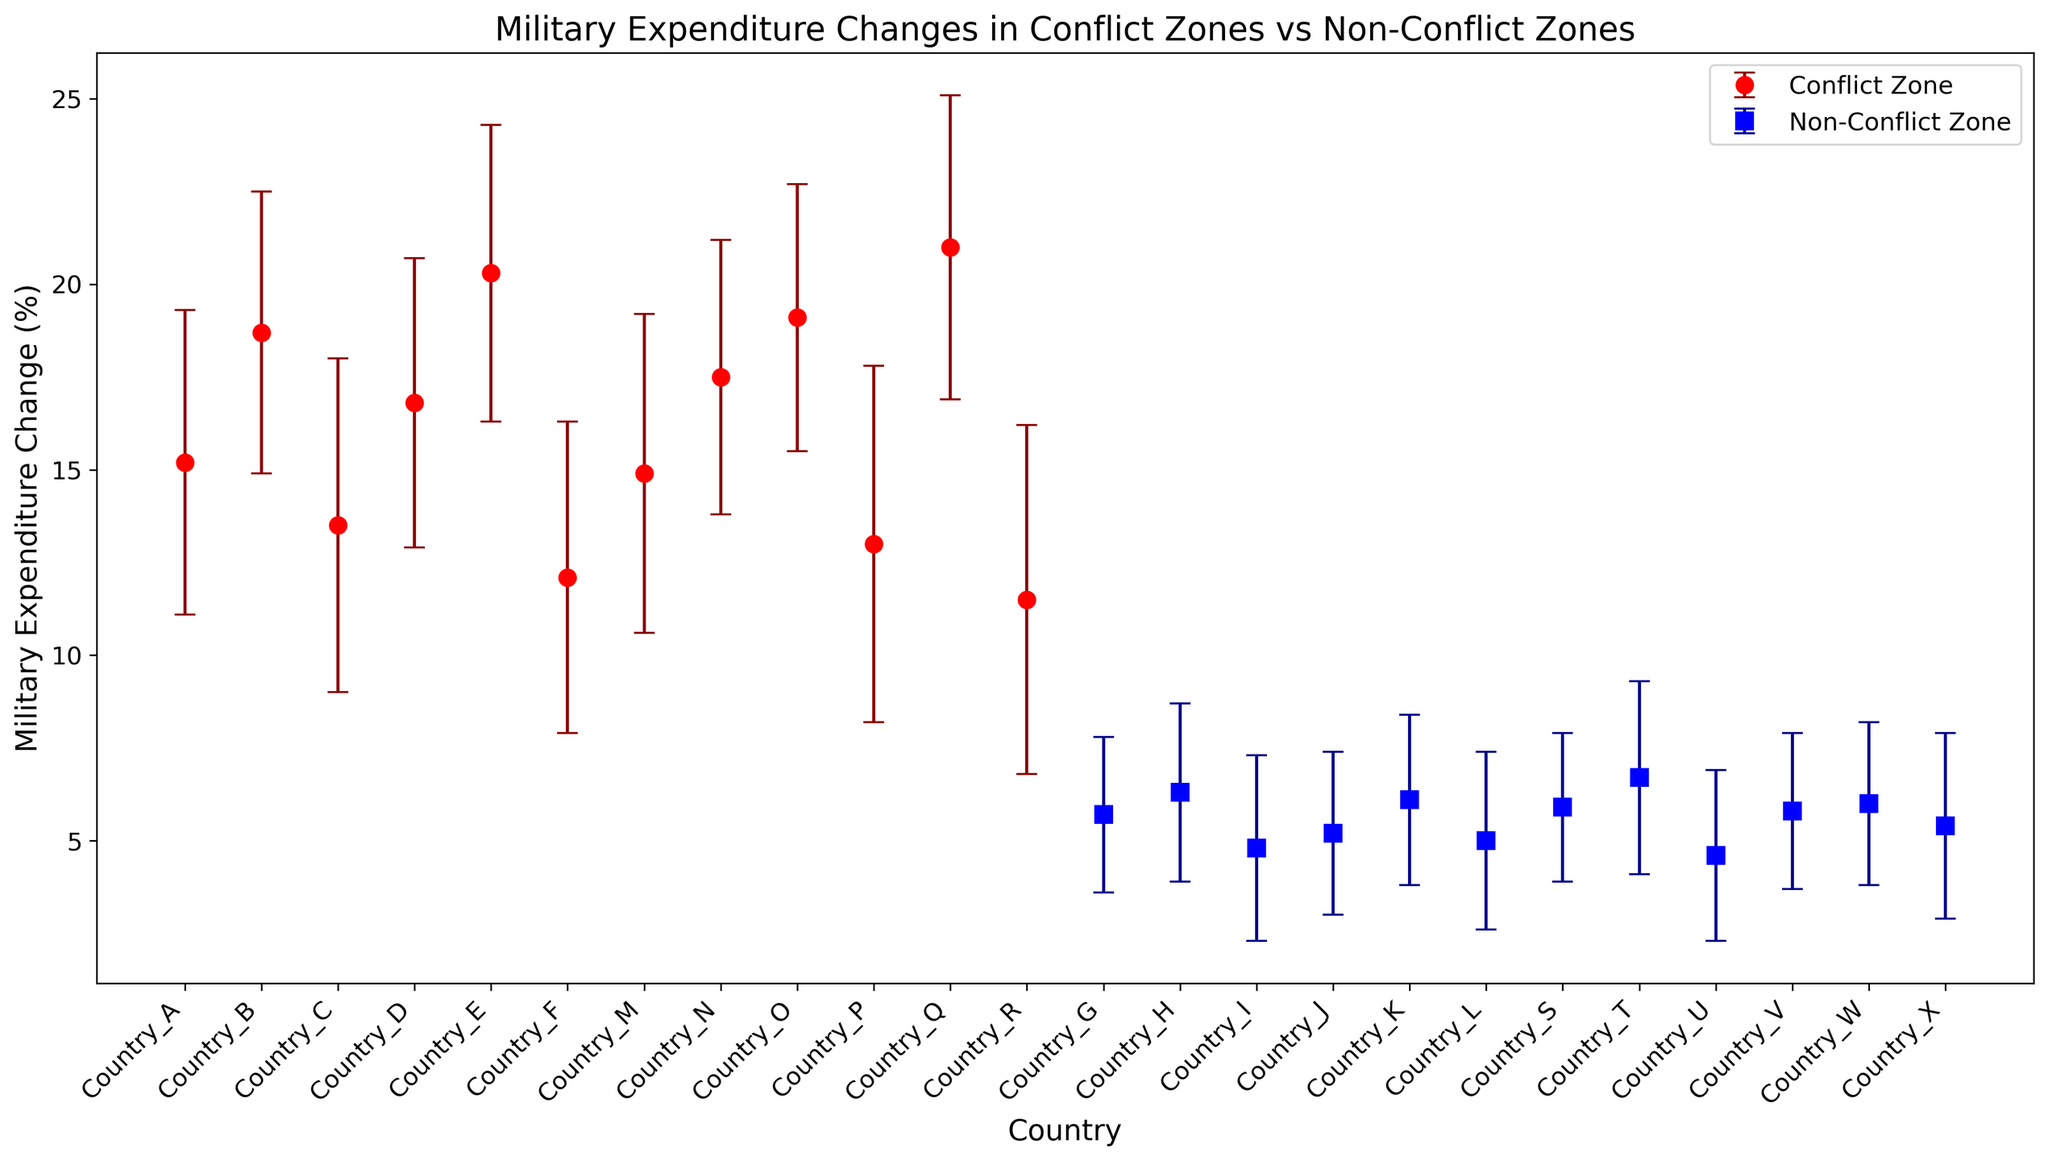How many countries are in the conflict zone category? By examining the data points in the red error bars labeled as conflict zones, we can count the number of countries.
Answer: 12 Which country shows the highest military expenditure change in conflict zones? Identify the red error bar with the highest point, because red error bars represent conflict zones. The country corresponding to that bar is the one we want.
Answer: Country_Q Which country in the non-conflict zone has the lowest military expenditure change? Look for the blue error bar that is the lowest on the y-axis since blue bars represent non-conflict zones. The country corresponding to this bar is the answer.
Answer: Country_U What is the average military expenditure change for conflict zones? Add up the military expenditure changes for all the conflict zones from the data and then divide by their count: (15.2 + 18.7 + 13.5 + 16.8 + 20.3 + 12.1 + 14.9 + 17.5 + 19.1 + 13.0 + 21.0 + 11.5)/12 = 15.875
Answer: 15.875 Which zone type, conflict or non-conflict, shows higher variability in military expenditure change on average? Compare the average standard deviations of both zone types. For conflict zones: (4.1 + 3.8 + 4.5 + 3.9 + 4.0 + 4.2 + 4.3 + 3.7 + 3.6 + 4.8 + 4.1 + 4.7) / 12 = 4.08. For non-conflict zones: (2.1 + 2.4 + 2.5 + 2.2 + 2.3 + 2.4 + 2.0 + 2.6 + 2.3 + 2.1 + 2.2 + 2.5) / 12 = 2.3.
Answer: Conflict Which country has the smallest standard deviation in non-conflict zones related to military expenditure change? Look for the blue error bar with the smallest vertical error range. The relevant country is the answer.
Answer: Country_S Are most conflict zone countries increasing or decreasing their military expenditure? Examine the red error bars' positions relative to the zero line on the y-axis. If mostly above zero, expenditures are increasing.
Answer: Increasing What is the median military expenditure change for non-conflict zones? Order the non-conflict zone military expenditure changes and find the middle value. Mid-values in ordered data (4.6, 4.8, 5.0, 5.2, 5.4, 5.7, 5.8, 5.9, 6.0, 6.1, 6.3, 6.7) are 5.55, so taken as (5.4+5.7)/2
Answer: 5.55 Compare the highest and lowest military expenditure changes in conflict zones and find the range. Identify the highest and lowest red error bars. Highest is 21.0 (Country_Q) and lowest is 11.5 (Country_R). Then subtract the smallest from the largest value: 21.0 - 11.5 = 9.5
Answer: 9.5 